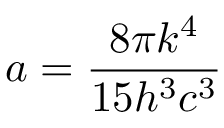<formula> <loc_0><loc_0><loc_500><loc_500>a = \frac { 8 \pi k ^ { 4 } } { 1 5 h ^ { 3 } c ^ { 3 } }</formula> 